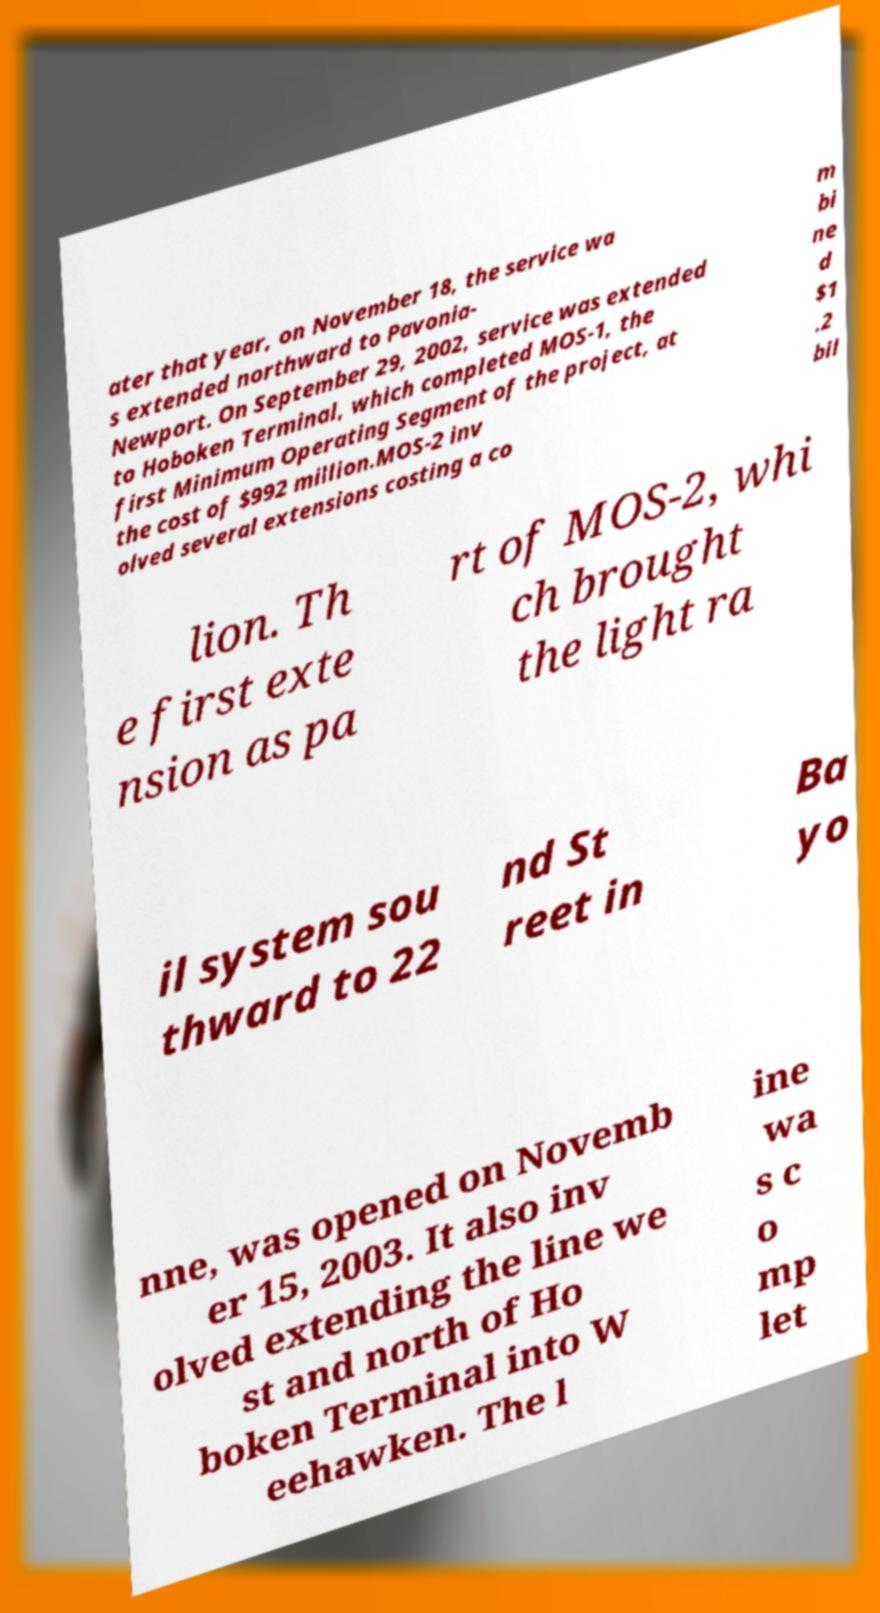There's text embedded in this image that I need extracted. Can you transcribe it verbatim? ater that year, on November 18, the service wa s extended northward to Pavonia- Newport. On September 29, 2002, service was extended to Hoboken Terminal, which completed MOS-1, the first Minimum Operating Segment of the project, at the cost of $992 million.MOS-2 inv olved several extensions costing a co m bi ne d $1 .2 bil lion. Th e first exte nsion as pa rt of MOS-2, whi ch brought the light ra il system sou thward to 22 nd St reet in Ba yo nne, was opened on Novemb er 15, 2003. It also inv olved extending the line we st and north of Ho boken Terminal into W eehawken. The l ine wa s c o mp let 